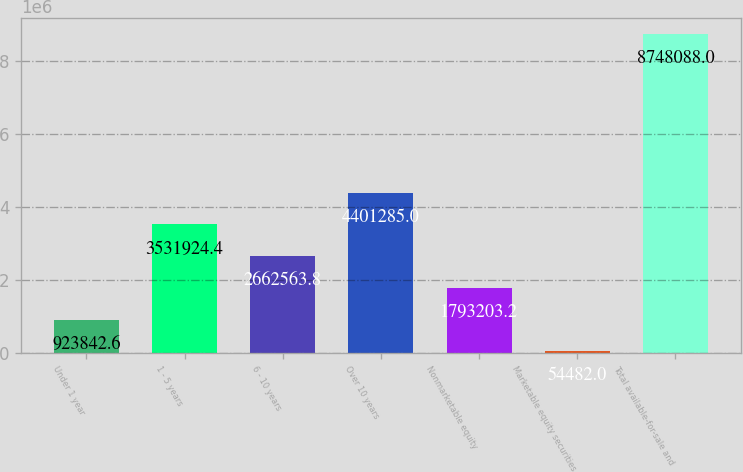<chart> <loc_0><loc_0><loc_500><loc_500><bar_chart><fcel>Under 1 year<fcel>1 - 5 years<fcel>6 - 10 years<fcel>Over 10 years<fcel>Nonmarketable equity<fcel>Marketable equity securities<fcel>Total available-for-sale and<nl><fcel>923843<fcel>3.53192e+06<fcel>2.66256e+06<fcel>4.40128e+06<fcel>1.7932e+06<fcel>54482<fcel>8.74809e+06<nl></chart> 